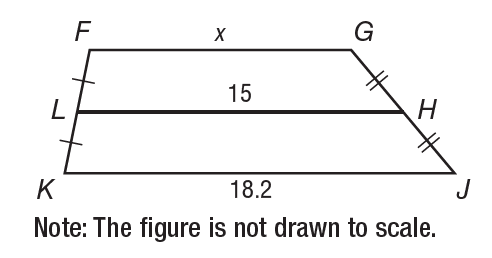Question: In the figure, L H is the midsegment of trapezoid F G J K. What is the value of x?
Choices:
A. 11.8
B. 15
C. 18.2
D. 33.2
Answer with the letter. Answer: A 